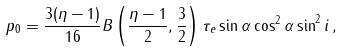Convert formula to latex. <formula><loc_0><loc_0><loc_500><loc_500>p _ { 0 } = \frac { 3 ( \eta - 1 ) } { 1 6 } B \left ( \frac { \eta - 1 } { 2 } , \frac { 3 } { 2 } \right ) \tau _ { e } \sin \alpha \cos ^ { 2 } \alpha \sin ^ { 2 } i \, ,</formula> 